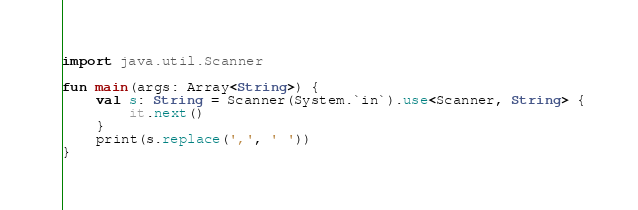Convert code to text. <code><loc_0><loc_0><loc_500><loc_500><_Kotlin_>import java.util.Scanner

fun main(args: Array<String>) {
    val s: String = Scanner(System.`in`).use<Scanner, String> {
        it.next()
    }
    print(s.replace(',', ' '))
}</code> 